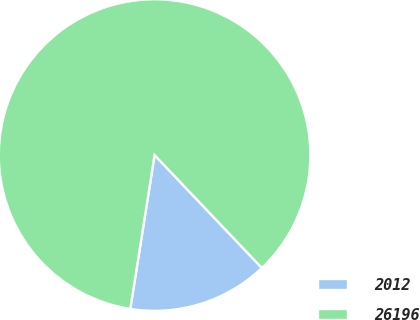Convert chart to OTSL. <chart><loc_0><loc_0><loc_500><loc_500><pie_chart><fcel>2012<fcel>26196<nl><fcel>14.59%<fcel>85.41%<nl></chart> 